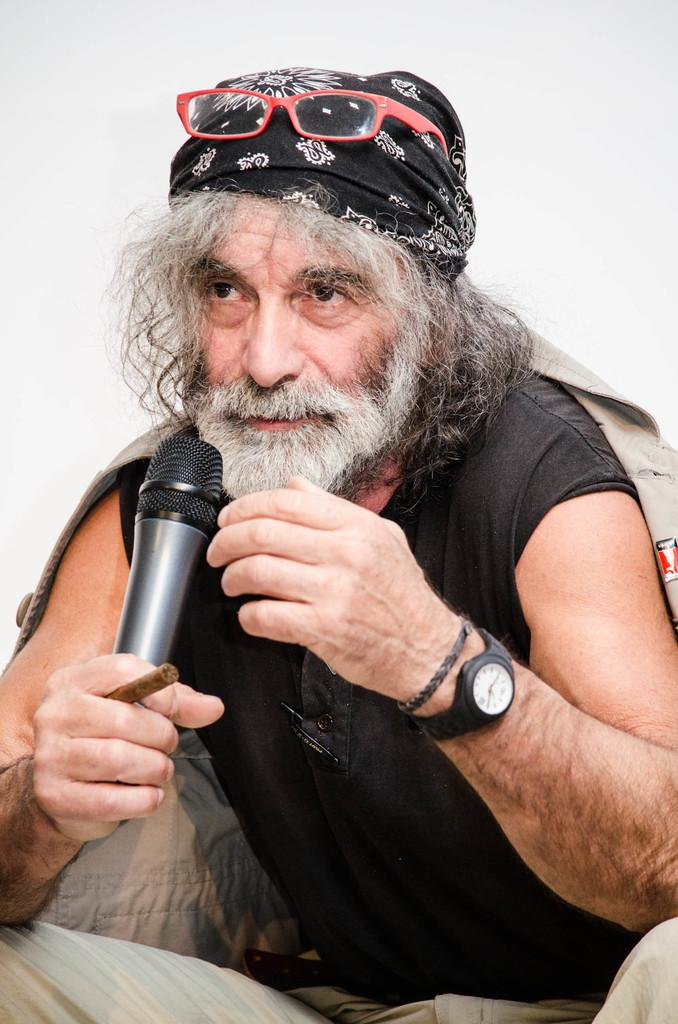What is the gender of the person in the image? The person in the image is a man. What is the man holding in the image? The man is holding a microphone. Can you describe the object between the man's fingers? There is an object between two fingers of the man, but it is not clear what it is from the image. What type of news is the man reporting in the image? There is no indication in the image that the man is reporting news, so it cannot be determined from the picture. 